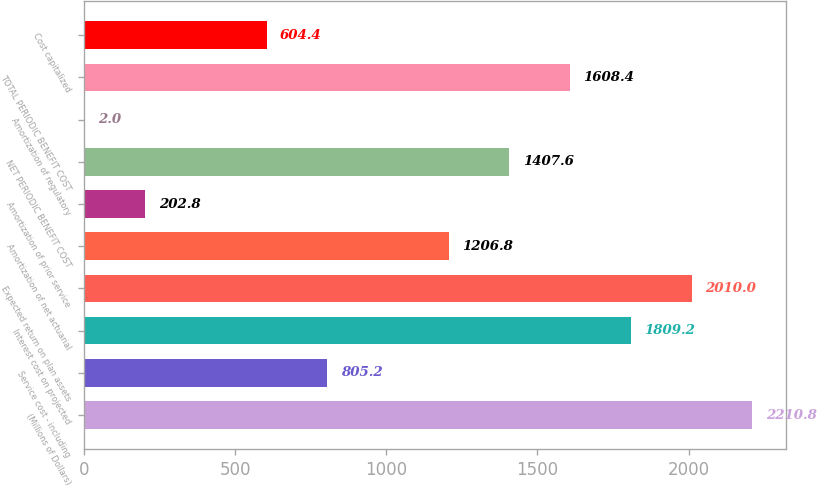Convert chart. <chart><loc_0><loc_0><loc_500><loc_500><bar_chart><fcel>(Millions of Dollars)<fcel>Service cost - including<fcel>Interest cost on projected<fcel>Expected return on plan assets<fcel>Amortization of net actuarial<fcel>Amortization of prior service<fcel>NET PERIODIC BENEFIT COST<fcel>Amortization of regulatory<fcel>TOTAL PERIODIC BENEFIT COST<fcel>Cost capitalized<nl><fcel>2210.8<fcel>805.2<fcel>1809.2<fcel>2010<fcel>1206.8<fcel>202.8<fcel>1407.6<fcel>2<fcel>1608.4<fcel>604.4<nl></chart> 